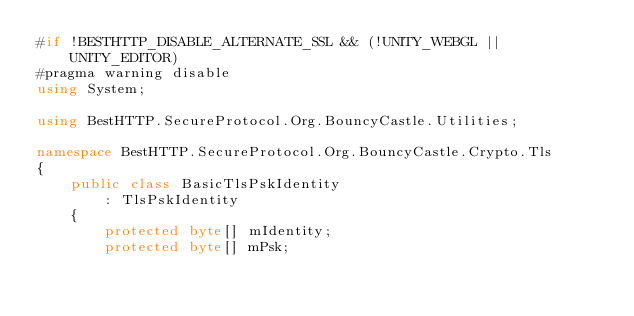<code> <loc_0><loc_0><loc_500><loc_500><_C#_>#if !BESTHTTP_DISABLE_ALTERNATE_SSL && (!UNITY_WEBGL || UNITY_EDITOR)
#pragma warning disable
using System;

using BestHTTP.SecureProtocol.Org.BouncyCastle.Utilities;

namespace BestHTTP.SecureProtocol.Org.BouncyCastle.Crypto.Tls
{
    public class BasicTlsPskIdentity
        : TlsPskIdentity
    {
        protected byte[] mIdentity;
        protected byte[] mPsk;
</code> 